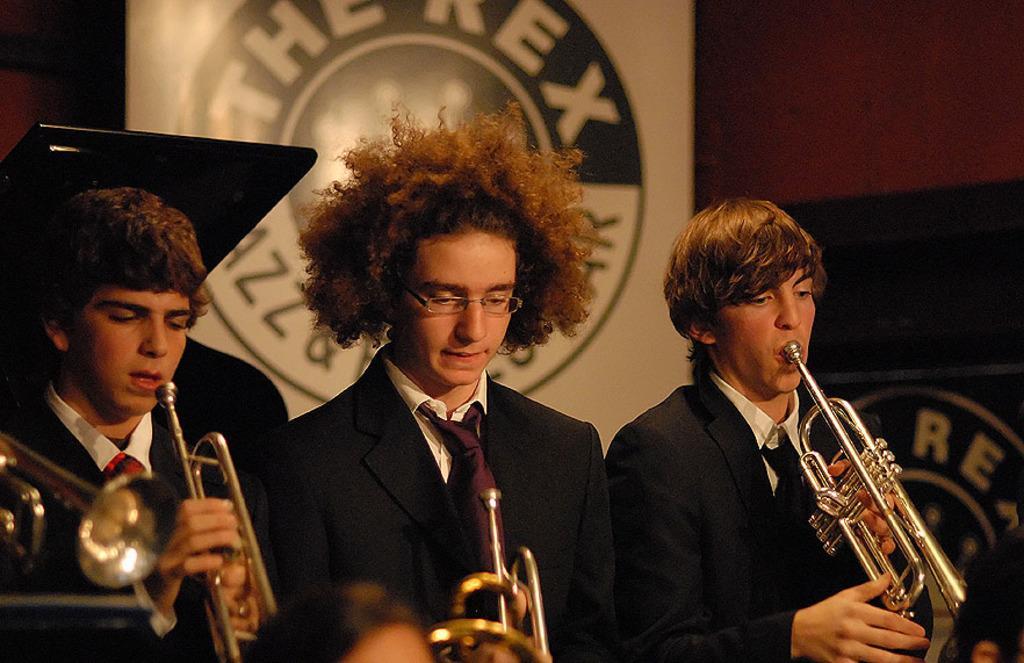How would you summarize this image in a sentence or two? In this image we can see three persons holding musical instruments in their hands and behind them, we can see a board with some text. 